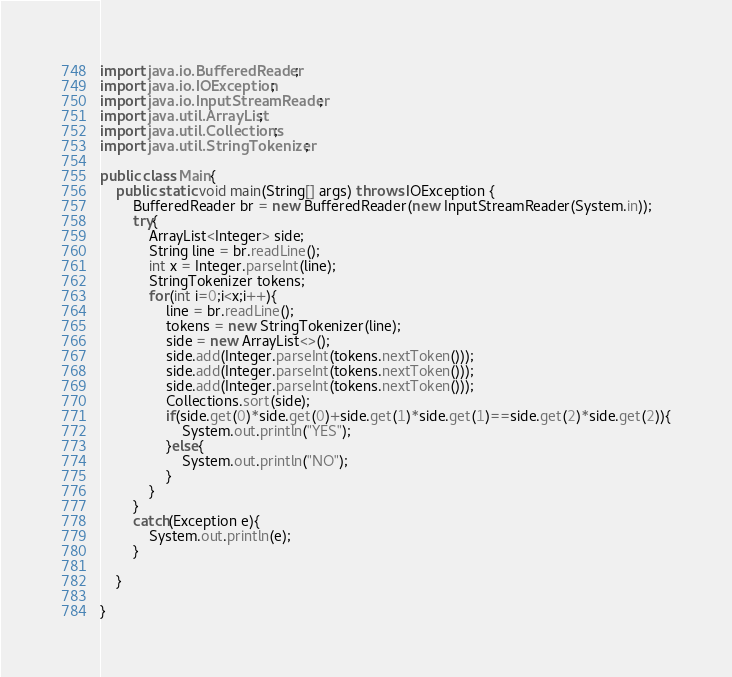Convert code to text. <code><loc_0><loc_0><loc_500><loc_500><_Java_>import java.io.BufferedReader;
import java.io.IOException;
import java.io.InputStreamReader;
import java.util.ArrayList;
import java.util.Collections;
import java.util.StringTokenizer;

public class Main{
    public static void main(String[] args) throws IOException {
        BufferedReader br = new BufferedReader(new InputStreamReader(System.in));
        try{
            ArrayList<Integer> side;
            String line = br.readLine();
            int x = Integer.parseInt(line);
            StringTokenizer tokens;
            for(int i=0;i<x;i++){
                line = br.readLine();
                tokens = new StringTokenizer(line);
                side = new ArrayList<>();
                side.add(Integer.parseInt(tokens.nextToken()));
                side.add(Integer.parseInt(tokens.nextToken()));
                side.add(Integer.parseInt(tokens.nextToken()));
                Collections.sort(side);
                if(side.get(0)*side.get(0)+side.get(1)*side.get(1)==side.get(2)*side.get(2)){
                    System.out.println("YES");
                }else{
                    System.out.println("NO");
                }
            }
        }
        catch(Exception e){
            System.out.println(e);
        }

    }

}</code> 